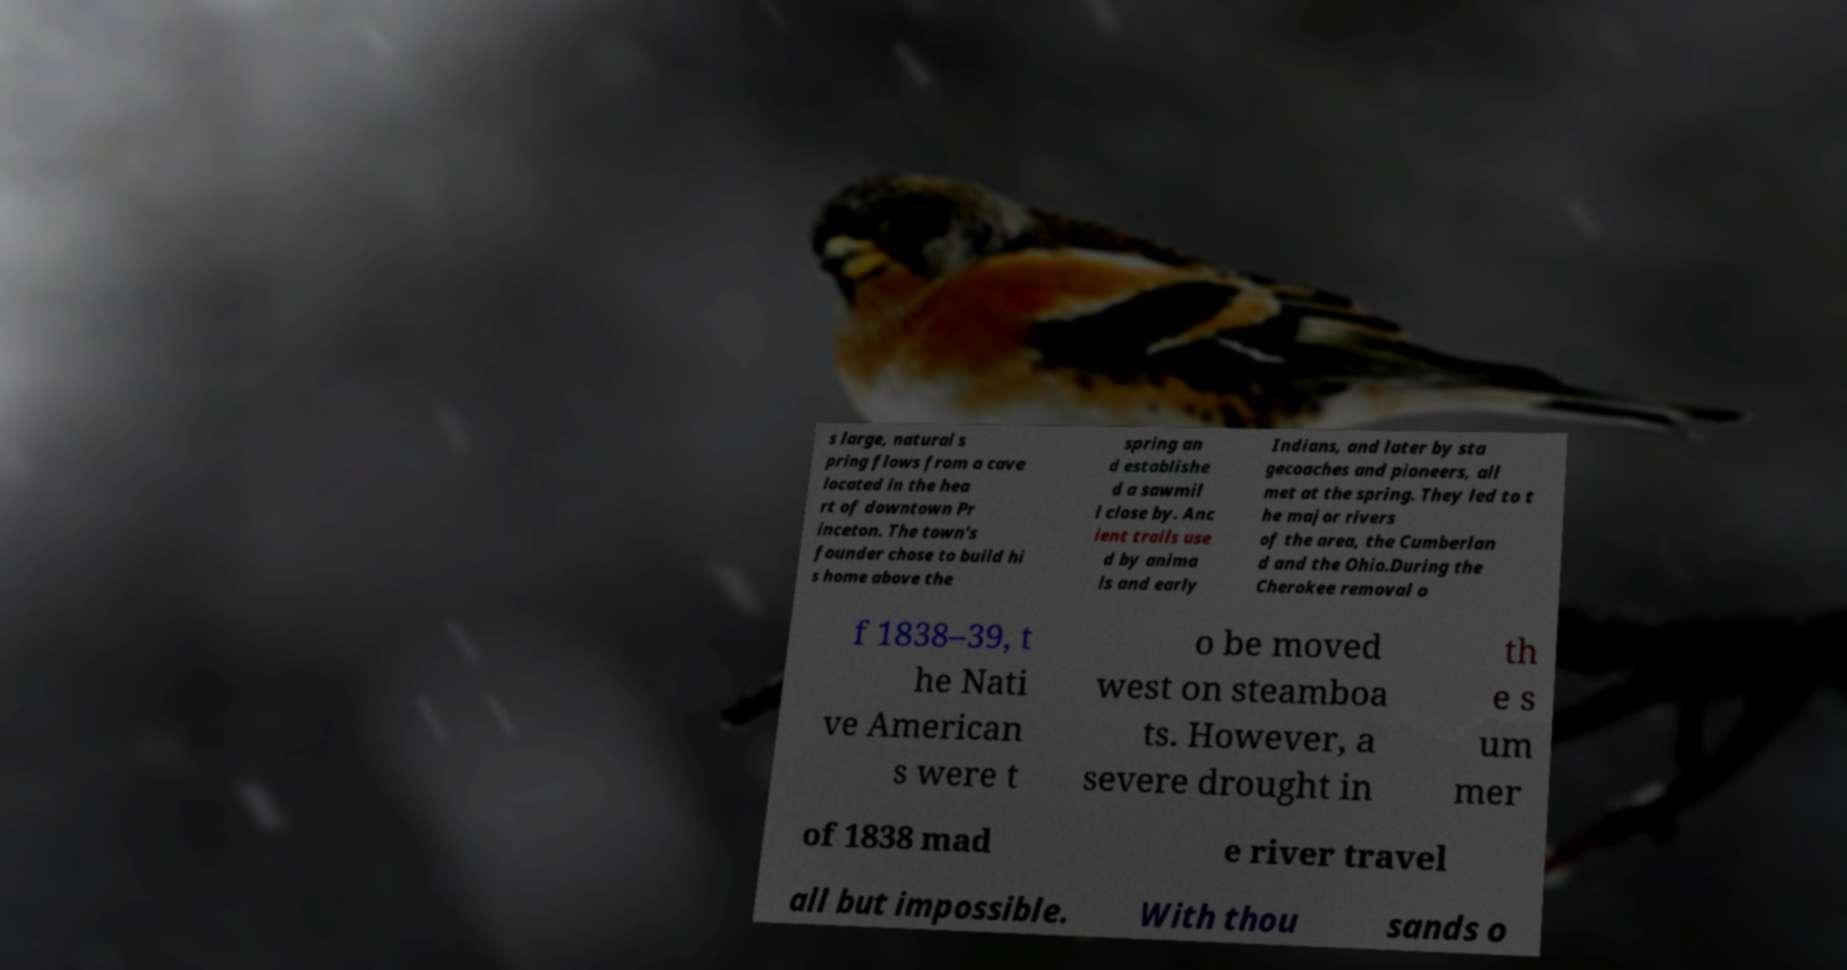Can you read and provide the text displayed in the image?This photo seems to have some interesting text. Can you extract and type it out for me? s large, natural s pring flows from a cave located in the hea rt of downtown Pr inceton. The town's founder chose to build hi s home above the spring an d establishe d a sawmil l close by. Anc ient trails use d by anima ls and early Indians, and later by sta gecoaches and pioneers, all met at the spring. They led to t he major rivers of the area, the Cumberlan d and the Ohio.During the Cherokee removal o f 1838–39, t he Nati ve American s were t o be moved west on steamboa ts. However, a severe drought in th e s um mer of 1838 mad e river travel all but impossible. With thou sands o 